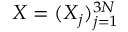<formula> <loc_0><loc_0><loc_500><loc_500>{ X } = ( X _ { j } ) _ { j = 1 } ^ { 3 N }</formula> 